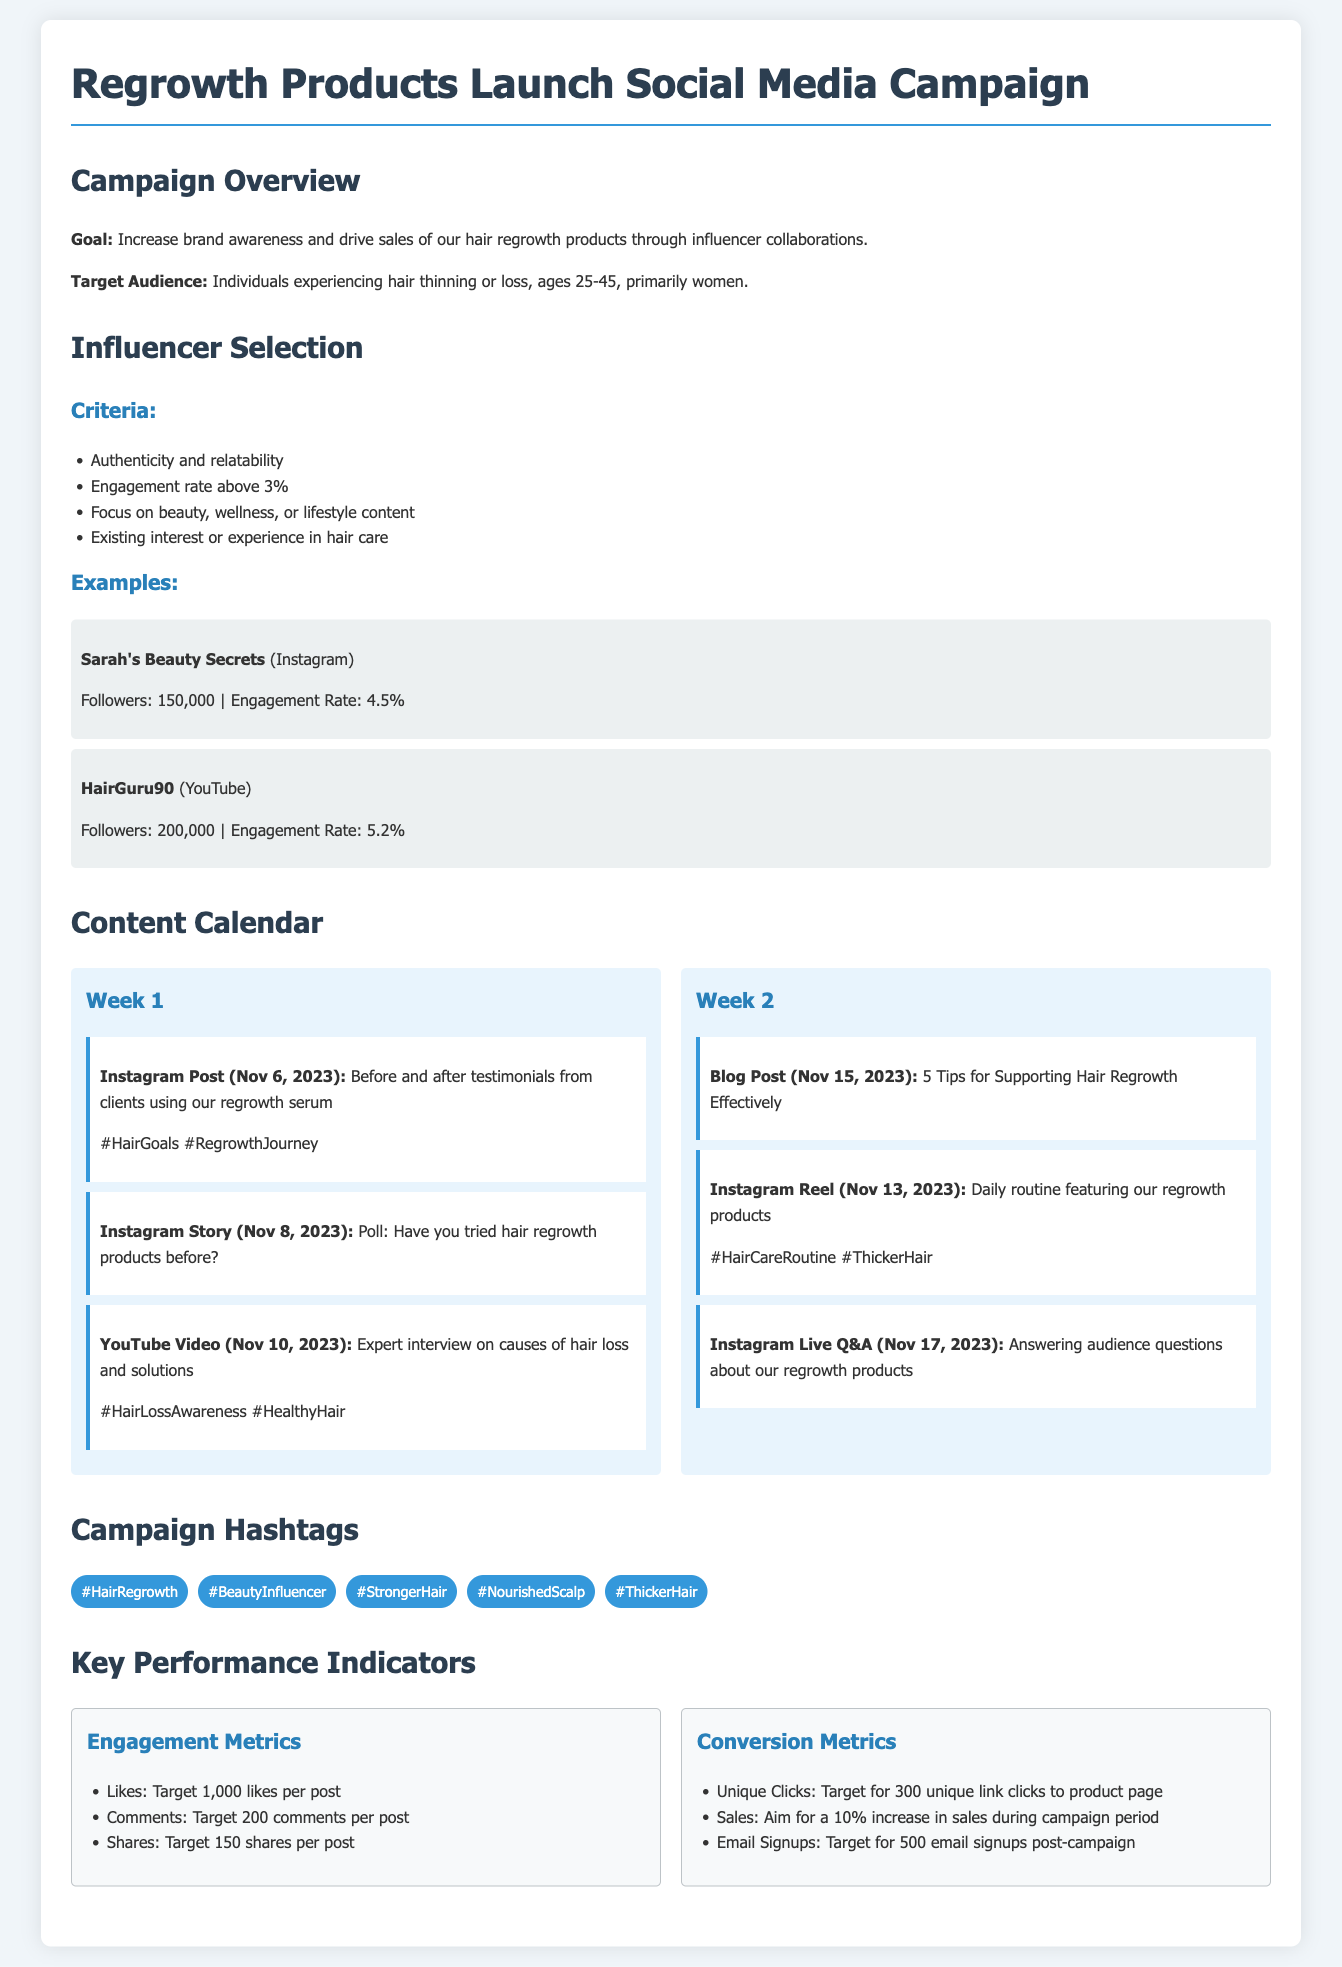what is the goal of the campaign? The goal of the campaign is to increase brand awareness and drive sales of hair regrowth products through influencer collaborations.
Answer: Increase brand awareness and drive sales who are the target audience for the campaign? The target audience includes individuals experiencing hair thinning or loss, specifically ages 25-45, primarily women.
Answer: Individuals experiencing hair thinning or loss, ages 25-45, primarily women what is the engagement rate required for influencers? The engagement rate required for influencers is above 3%.
Answer: Above 3% which influencer has an engagement rate of 4.5%? Sarah's Beauty Secrets has an engagement rate of 4.5%.
Answer: Sarah's Beauty Secrets what is one of the content items scheduled for Week 1? One of the content items scheduled for Week 1 is an Instagram Post with before and after testimonials from clients.
Answer: Instagram Post (Nov 6, 2023) how many unique clicks are targeted from the campaign? The target for unique clicks to the product page is 300.
Answer: 300 list one of the campaign hashtags. One of the campaign hashtags is #HairRegrowth.
Answer: #HairRegrowth what is the aim for sales during the campaign? The aim for sales during the campaign is a 10% increase.
Answer: 10% increase what is the expected number of email signups post-campaign? The target for email signups post-campaign is 500.
Answer: 500 